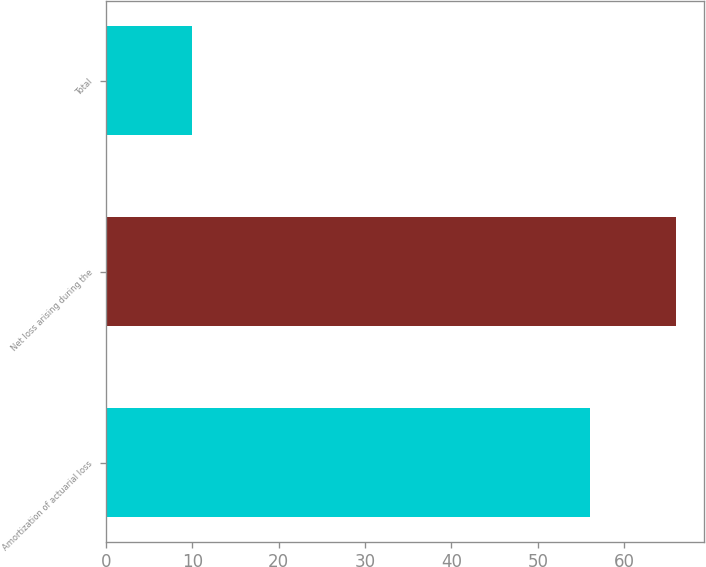Convert chart to OTSL. <chart><loc_0><loc_0><loc_500><loc_500><bar_chart><fcel>Amortization of actuarial loss<fcel>Net loss arising during the<fcel>Total<nl><fcel>56<fcel>66<fcel>10<nl></chart> 